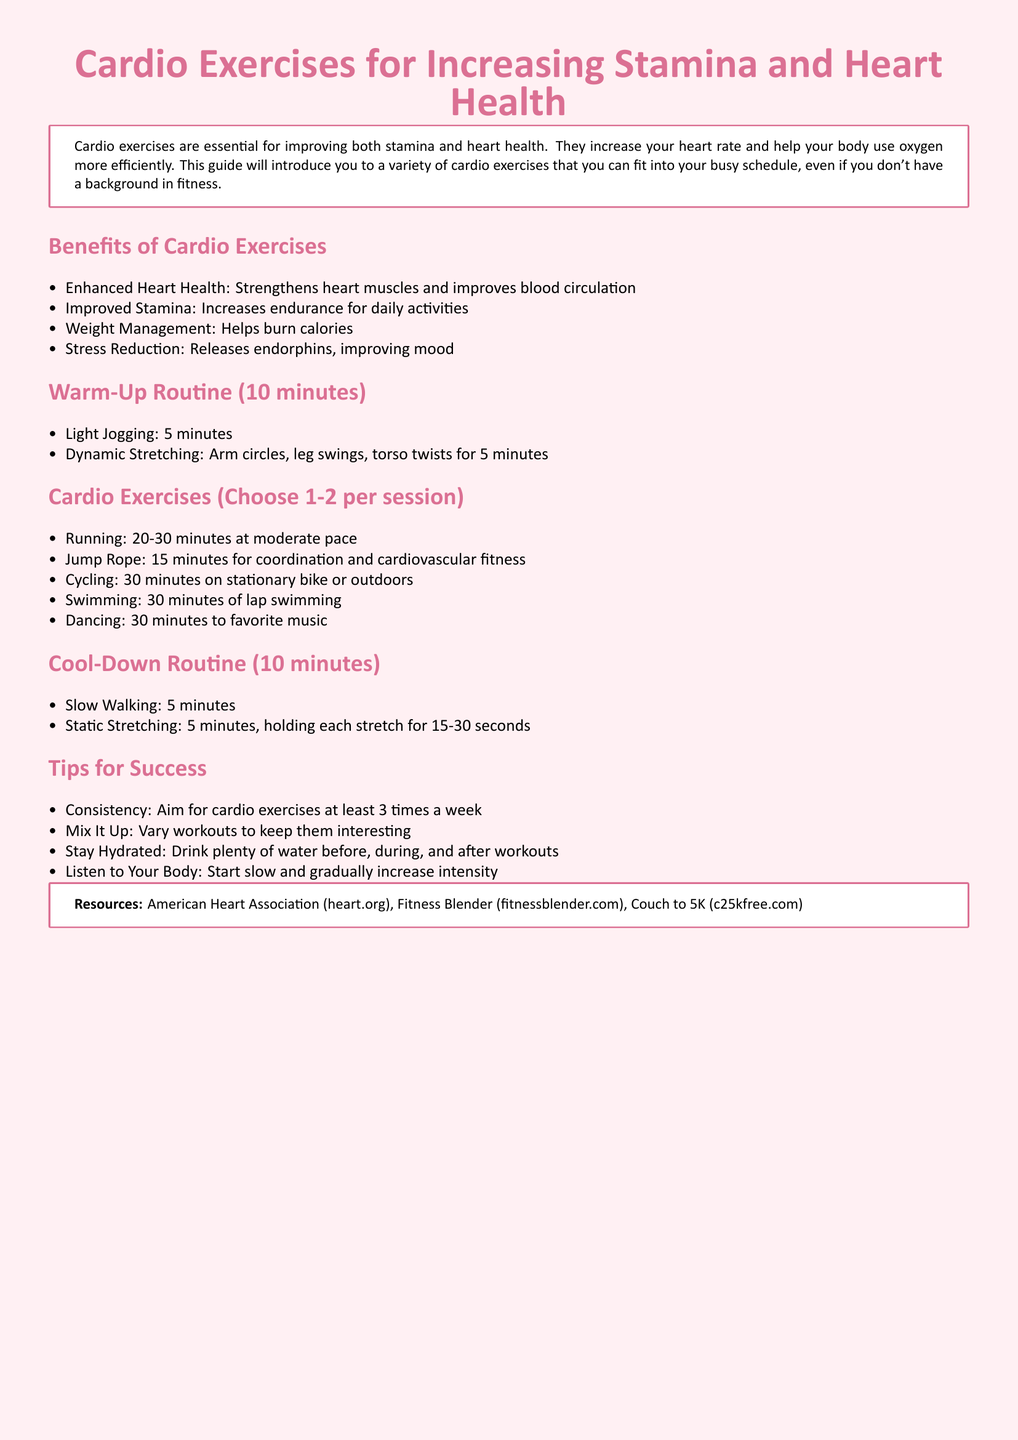What are the benefits of cardio exercises? The document lists benefits such as enhanced heart health, improved stamina, weight management, and stress reduction.
Answer: Enhanced Heart Health, Improved Stamina, Weight Management, Stress Reduction What is the duration of the warm-up routine? The warm-up routine in the document is specified to last for 10 minutes.
Answer: 10 minutes How long should one run during the cardio exercises? The document suggests a running duration of 20-30 minutes at a moderate pace.
Answer: 20-30 minutes What should one do for the cool-down routine? The cool-down routine consists of slow walking and static stretching for specific durations, totaling 10 minutes.
Answer: Slow Walking and Static Stretching How many times a week should cardio exercises be done for consistency? The document recommends performing cardio exercises at least 3 times a week.
Answer: 3 times a week Which cardio exercise is suggested for coordination? Jump rope is mentioned in the document as an exercise for coordination.
Answer: Jump Rope How long should one cycle according to the workout plan? The document states that cycling should be for 30 minutes either on a stationary bike or outdoors.
Answer: 30 minutes What is one essential tip provided for success in cardio exercises? The document suggests staying hydrated as an essential tip for success.
Answer: Stay Hydrated 